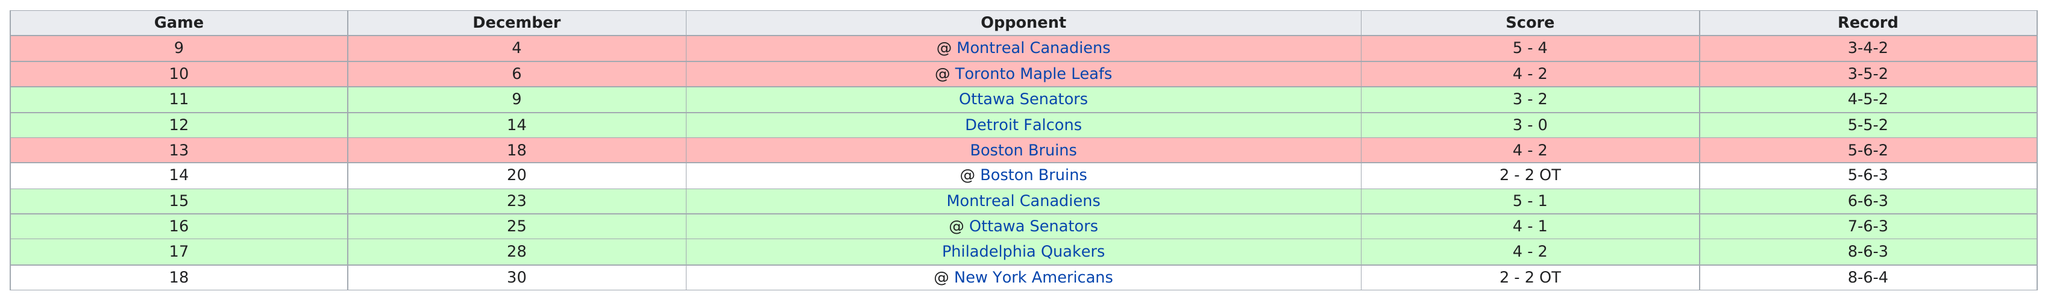Point out several critical features in this image. In November, the total number of games played was 8. In January, there were more games played compared to December. During the months of February and March, the combined total of wins amounted to 9. December had the same number of road wins as January, which is quite remarkable considering the difference in length between the two months. In December 1930, the New York Rangers won a total of 1 road game. 